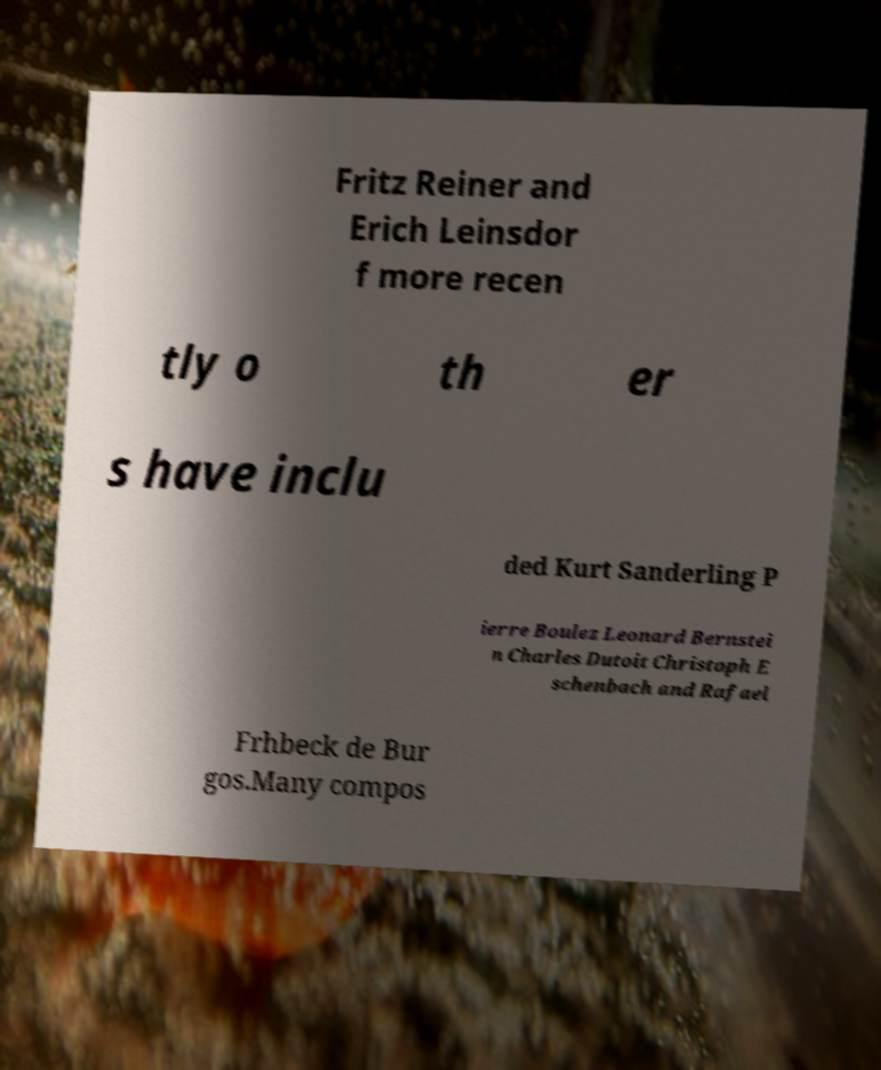Can you accurately transcribe the text from the provided image for me? Fritz Reiner and Erich Leinsdor f more recen tly o th er s have inclu ded Kurt Sanderling P ierre Boulez Leonard Bernstei n Charles Dutoit Christoph E schenbach and Rafael Frhbeck de Bur gos.Many compos 